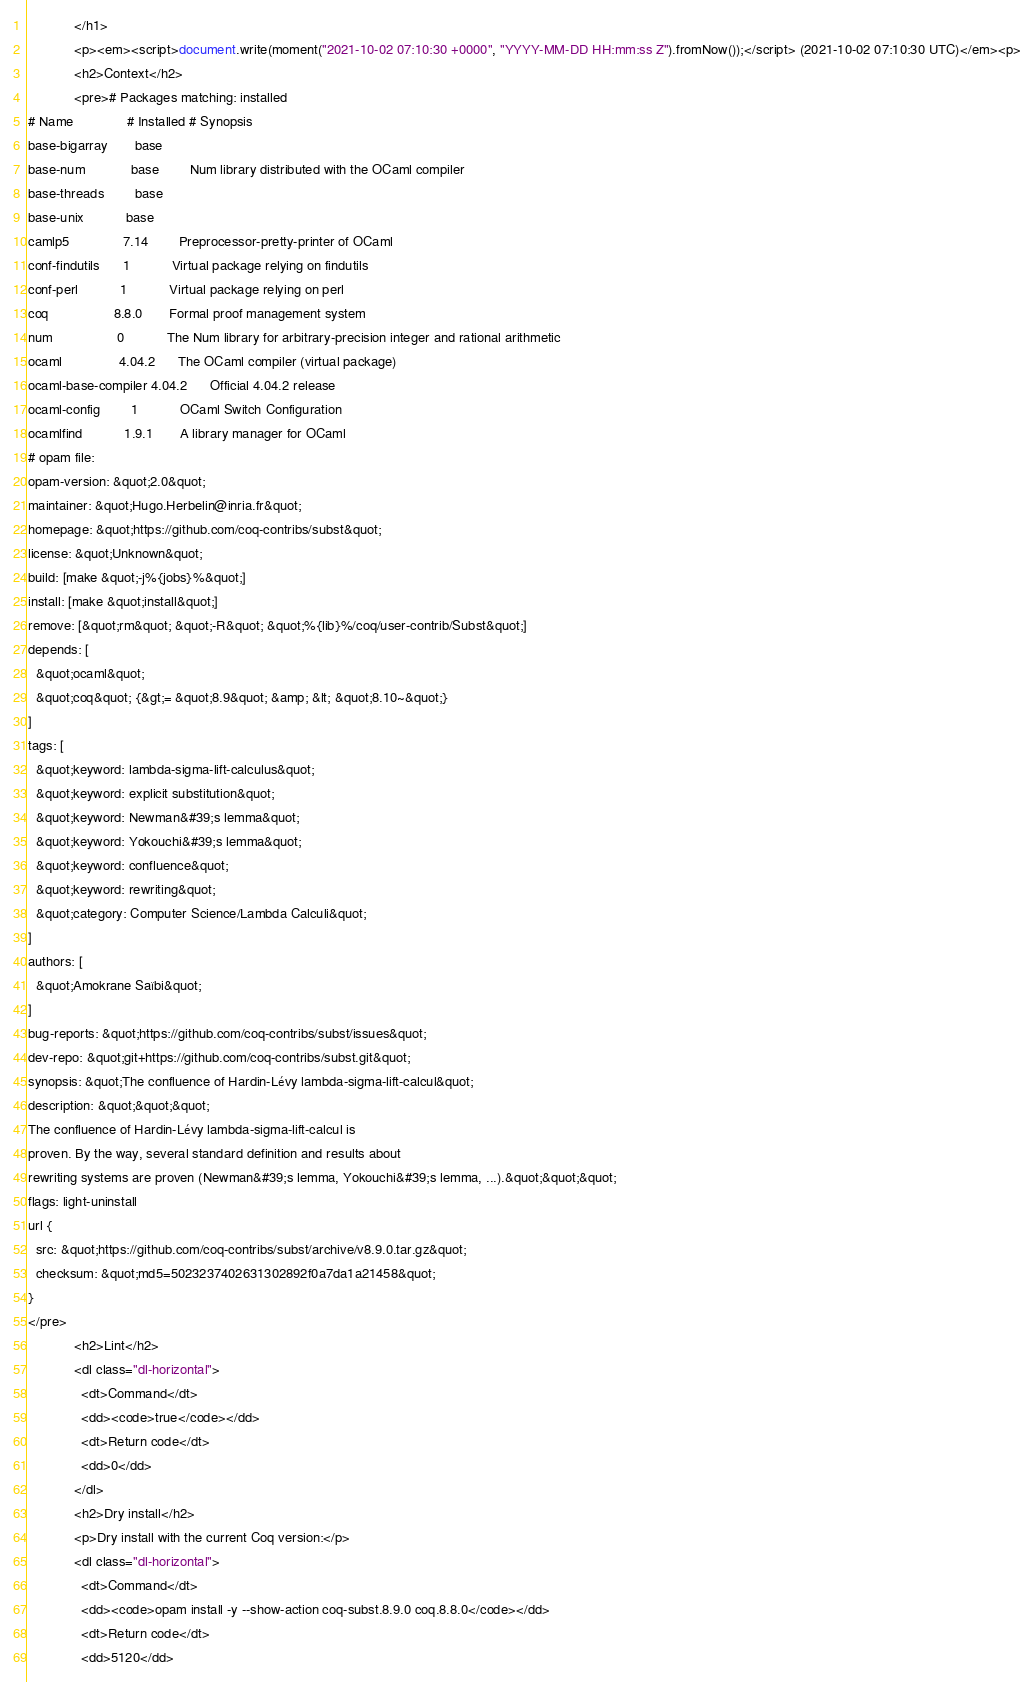Convert code to text. <code><loc_0><loc_0><loc_500><loc_500><_HTML_>            </h1>
            <p><em><script>document.write(moment("2021-10-02 07:10:30 +0000", "YYYY-MM-DD HH:mm:ss Z").fromNow());</script> (2021-10-02 07:10:30 UTC)</em><p>
            <h2>Context</h2>
            <pre># Packages matching: installed
# Name              # Installed # Synopsis
base-bigarray       base
base-num            base        Num library distributed with the OCaml compiler
base-threads        base
base-unix           base
camlp5              7.14        Preprocessor-pretty-printer of OCaml
conf-findutils      1           Virtual package relying on findutils
conf-perl           1           Virtual package relying on perl
coq                 8.8.0       Formal proof management system
num                 0           The Num library for arbitrary-precision integer and rational arithmetic
ocaml               4.04.2      The OCaml compiler (virtual package)
ocaml-base-compiler 4.04.2      Official 4.04.2 release
ocaml-config        1           OCaml Switch Configuration
ocamlfind           1.9.1       A library manager for OCaml
# opam file:
opam-version: &quot;2.0&quot;
maintainer: &quot;Hugo.Herbelin@inria.fr&quot;
homepage: &quot;https://github.com/coq-contribs/subst&quot;
license: &quot;Unknown&quot;
build: [make &quot;-j%{jobs}%&quot;]
install: [make &quot;install&quot;]
remove: [&quot;rm&quot; &quot;-R&quot; &quot;%{lib}%/coq/user-contrib/Subst&quot;]
depends: [
  &quot;ocaml&quot;
  &quot;coq&quot; {&gt;= &quot;8.9&quot; &amp; &lt; &quot;8.10~&quot;}
]
tags: [
  &quot;keyword: lambda-sigma-lift-calculus&quot;
  &quot;keyword: explicit substitution&quot;
  &quot;keyword: Newman&#39;s lemma&quot;
  &quot;keyword: Yokouchi&#39;s lemma&quot;
  &quot;keyword: confluence&quot;
  &quot;keyword: rewriting&quot;
  &quot;category: Computer Science/Lambda Calculi&quot;
]
authors: [
  &quot;Amokrane Saïbi&quot;
]
bug-reports: &quot;https://github.com/coq-contribs/subst/issues&quot;
dev-repo: &quot;git+https://github.com/coq-contribs/subst.git&quot;
synopsis: &quot;The confluence of Hardin-Lévy lambda-sigma-lift-calcul&quot;
description: &quot;&quot;&quot;
The confluence of Hardin-Lévy lambda-sigma-lift-calcul is
proven. By the way, several standard definition and results about
rewriting systems are proven (Newman&#39;s lemma, Yokouchi&#39;s lemma, ...).&quot;&quot;&quot;
flags: light-uninstall
url {
  src: &quot;https://github.com/coq-contribs/subst/archive/v8.9.0.tar.gz&quot;
  checksum: &quot;md5=5023237402631302892f0a7da1a21458&quot;
}
</pre>
            <h2>Lint</h2>
            <dl class="dl-horizontal">
              <dt>Command</dt>
              <dd><code>true</code></dd>
              <dt>Return code</dt>
              <dd>0</dd>
            </dl>
            <h2>Dry install</h2>
            <p>Dry install with the current Coq version:</p>
            <dl class="dl-horizontal">
              <dt>Command</dt>
              <dd><code>opam install -y --show-action coq-subst.8.9.0 coq.8.8.0</code></dd>
              <dt>Return code</dt>
              <dd>5120</dd></code> 